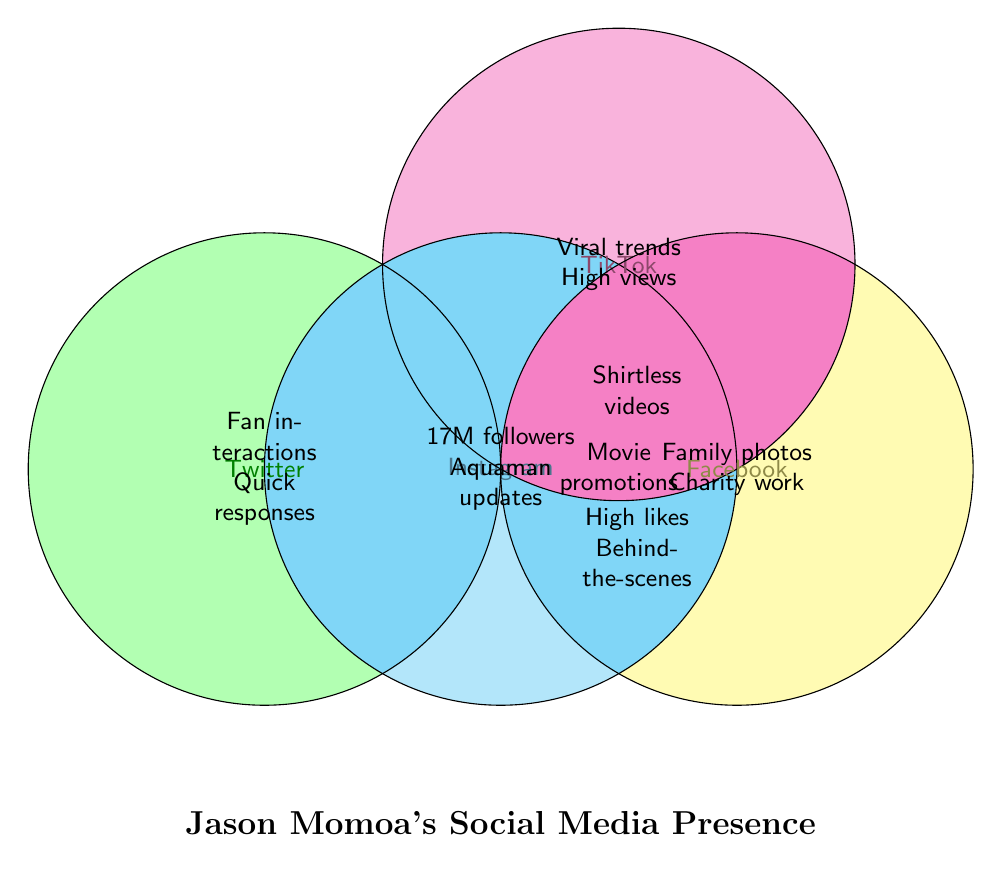How many types of content are posted on Instagram? Review the area marked "Instagram" in the Venn diagram and count the different types of content listed within or overlapping Instagram.
Answer: 4 types Which platforms contain family photos? Look for the area labeled "Family photos" and identify the overlapping platform.
Answer: Facebook Which content type overlaps between TikTok and Instagram? Identify content that appears in both TikTok and Instagram's overlapping sections in the Venn diagram.
Answer: Shirtless videos Which platform has the highest number of followers? Look at the followers' count mentioned in any platform's section. Note that "17M followers" is shown in the Instagram section.
Answer: Instagram Where can you find high engagement in terms of likes and views? Identify the sections labeled "High likes" and "High views," and note the corresponding platforms.
Answer: Instagram and TikTok What kind of updates about Aquaman can be found, and on which platform? Search for the content type "Aquaman updates" and see which platform it is associated with in the Venn diagram.
Answer: Instagram Which platform is associated with charity work? Look for the content labeled "Charity work" and see which platform contains it in the Venn diagram.
Answer: Facebook Which platform focuses on quick responses and fan interactions? Examine the sections for content type "Quick responses" and "Fan interactions" to identify the platform.
Answer: Twitter Are there any platforms where both movie promotions and fan interactions are found? Determine if there is an overlapping section that contains both "Movie promotions" and "Fan interactions."
Answer: None What is the content overlap between Instagram and Facebook? Review the sections where Instagram and Facebook overlap to figure out shared content types.
Answer: High likes, Behind-the-scenes 